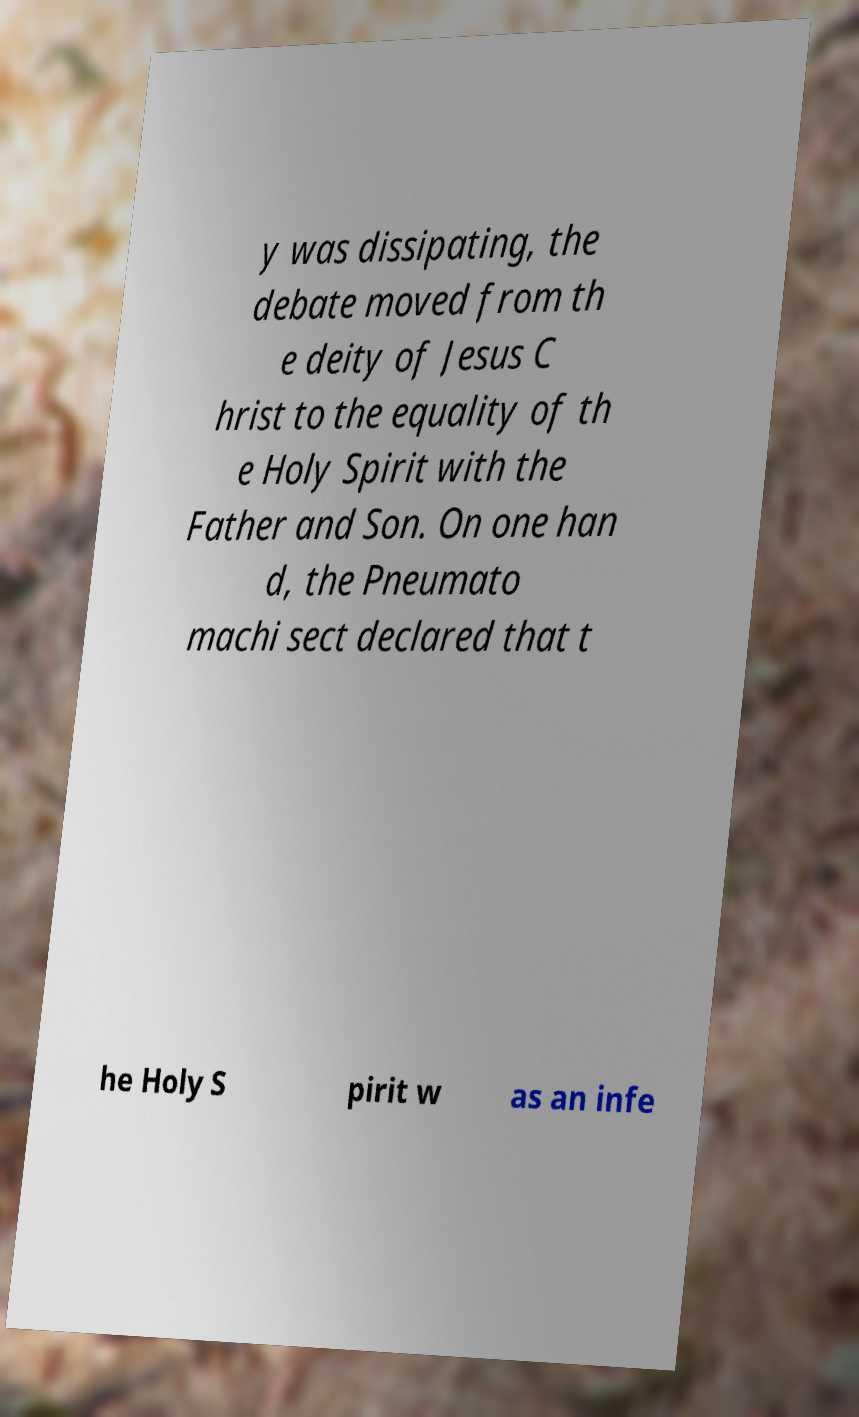Can you accurately transcribe the text from the provided image for me? y was dissipating, the debate moved from th e deity of Jesus C hrist to the equality of th e Holy Spirit with the Father and Son. On one han d, the Pneumato machi sect declared that t he Holy S pirit w as an infe 